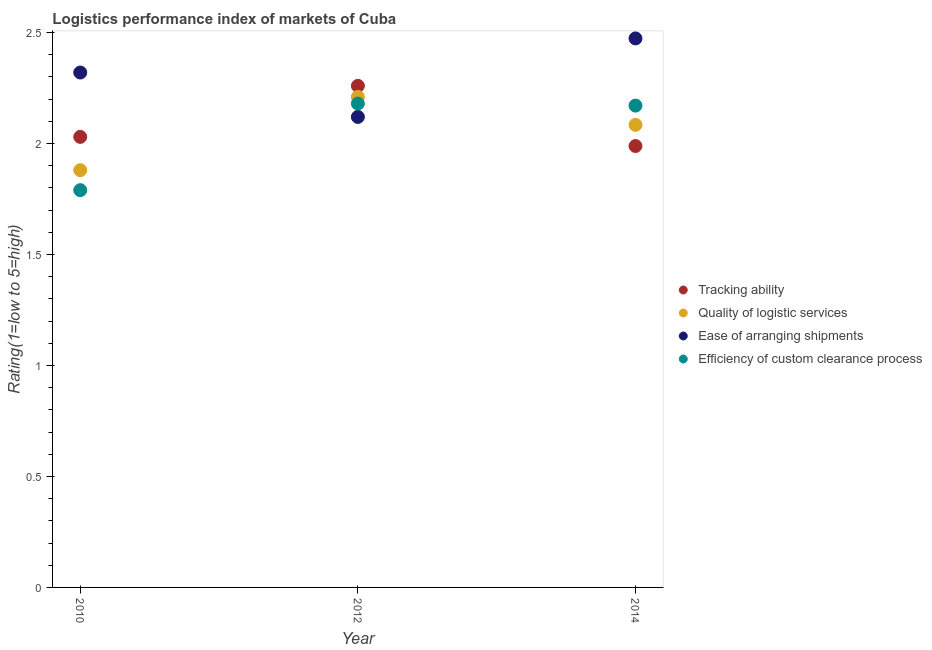How many different coloured dotlines are there?
Your response must be concise. 4. What is the lpi rating of ease of arranging shipments in 2012?
Your answer should be compact. 2.12. Across all years, what is the maximum lpi rating of quality of logistic services?
Offer a very short reply. 2.21. Across all years, what is the minimum lpi rating of ease of arranging shipments?
Your answer should be very brief. 2.12. In which year was the lpi rating of quality of logistic services maximum?
Offer a terse response. 2012. In which year was the lpi rating of tracking ability minimum?
Give a very brief answer. 2014. What is the total lpi rating of efficiency of custom clearance process in the graph?
Your answer should be compact. 6.14. What is the difference between the lpi rating of ease of arranging shipments in 2010 and that in 2014?
Provide a succinct answer. -0.15. What is the difference between the lpi rating of efficiency of custom clearance process in 2014 and the lpi rating of tracking ability in 2012?
Provide a short and direct response. -0.09. What is the average lpi rating of quality of logistic services per year?
Keep it short and to the point. 2.06. In the year 2010, what is the difference between the lpi rating of ease of arranging shipments and lpi rating of tracking ability?
Provide a short and direct response. 0.29. In how many years, is the lpi rating of quality of logistic services greater than 1.7?
Make the answer very short. 3. What is the ratio of the lpi rating of tracking ability in 2012 to that in 2014?
Offer a terse response. 1.14. Is the lpi rating of efficiency of custom clearance process in 2012 less than that in 2014?
Keep it short and to the point. No. Is the difference between the lpi rating of quality of logistic services in 2010 and 2012 greater than the difference between the lpi rating of ease of arranging shipments in 2010 and 2012?
Give a very brief answer. No. What is the difference between the highest and the second highest lpi rating of ease of arranging shipments?
Make the answer very short. 0.15. What is the difference between the highest and the lowest lpi rating of efficiency of custom clearance process?
Ensure brevity in your answer.  0.39. Is the sum of the lpi rating of ease of arranging shipments in 2012 and 2014 greater than the maximum lpi rating of tracking ability across all years?
Your answer should be very brief. Yes. Is it the case that in every year, the sum of the lpi rating of tracking ability and lpi rating of quality of logistic services is greater than the sum of lpi rating of efficiency of custom clearance process and lpi rating of ease of arranging shipments?
Make the answer very short. No. How many years are there in the graph?
Give a very brief answer. 3. What is the difference between two consecutive major ticks on the Y-axis?
Provide a short and direct response. 0.5. Are the values on the major ticks of Y-axis written in scientific E-notation?
Give a very brief answer. No. Does the graph contain any zero values?
Offer a terse response. No. How many legend labels are there?
Your answer should be very brief. 4. How are the legend labels stacked?
Your answer should be compact. Vertical. What is the title of the graph?
Provide a succinct answer. Logistics performance index of markets of Cuba. What is the label or title of the Y-axis?
Make the answer very short. Rating(1=low to 5=high). What is the Rating(1=low to 5=high) of Tracking ability in 2010?
Provide a succinct answer. 2.03. What is the Rating(1=low to 5=high) in Quality of logistic services in 2010?
Your answer should be very brief. 1.88. What is the Rating(1=low to 5=high) of Ease of arranging shipments in 2010?
Provide a succinct answer. 2.32. What is the Rating(1=low to 5=high) in Efficiency of custom clearance process in 2010?
Your response must be concise. 1.79. What is the Rating(1=low to 5=high) of Tracking ability in 2012?
Provide a short and direct response. 2.26. What is the Rating(1=low to 5=high) of Quality of logistic services in 2012?
Provide a succinct answer. 2.21. What is the Rating(1=low to 5=high) in Ease of arranging shipments in 2012?
Provide a short and direct response. 2.12. What is the Rating(1=low to 5=high) in Efficiency of custom clearance process in 2012?
Provide a short and direct response. 2.18. What is the Rating(1=low to 5=high) in Tracking ability in 2014?
Your response must be concise. 1.99. What is the Rating(1=low to 5=high) in Quality of logistic services in 2014?
Provide a succinct answer. 2.08. What is the Rating(1=low to 5=high) in Ease of arranging shipments in 2014?
Your response must be concise. 2.47. What is the Rating(1=low to 5=high) in Efficiency of custom clearance process in 2014?
Offer a terse response. 2.17. Across all years, what is the maximum Rating(1=low to 5=high) of Tracking ability?
Offer a very short reply. 2.26. Across all years, what is the maximum Rating(1=low to 5=high) in Quality of logistic services?
Give a very brief answer. 2.21. Across all years, what is the maximum Rating(1=low to 5=high) in Ease of arranging shipments?
Your answer should be compact. 2.47. Across all years, what is the maximum Rating(1=low to 5=high) of Efficiency of custom clearance process?
Provide a succinct answer. 2.18. Across all years, what is the minimum Rating(1=low to 5=high) of Tracking ability?
Ensure brevity in your answer.  1.99. Across all years, what is the minimum Rating(1=low to 5=high) in Quality of logistic services?
Your answer should be very brief. 1.88. Across all years, what is the minimum Rating(1=low to 5=high) in Ease of arranging shipments?
Provide a short and direct response. 2.12. Across all years, what is the minimum Rating(1=low to 5=high) of Efficiency of custom clearance process?
Keep it short and to the point. 1.79. What is the total Rating(1=low to 5=high) of Tracking ability in the graph?
Give a very brief answer. 6.28. What is the total Rating(1=low to 5=high) in Quality of logistic services in the graph?
Make the answer very short. 6.17. What is the total Rating(1=low to 5=high) of Ease of arranging shipments in the graph?
Your answer should be very brief. 6.91. What is the total Rating(1=low to 5=high) of Efficiency of custom clearance process in the graph?
Your response must be concise. 6.14. What is the difference between the Rating(1=low to 5=high) of Tracking ability in 2010 and that in 2012?
Ensure brevity in your answer.  -0.23. What is the difference between the Rating(1=low to 5=high) in Quality of logistic services in 2010 and that in 2012?
Your answer should be compact. -0.33. What is the difference between the Rating(1=low to 5=high) of Ease of arranging shipments in 2010 and that in 2012?
Your answer should be very brief. 0.2. What is the difference between the Rating(1=low to 5=high) of Efficiency of custom clearance process in 2010 and that in 2012?
Your response must be concise. -0.39. What is the difference between the Rating(1=low to 5=high) of Tracking ability in 2010 and that in 2014?
Give a very brief answer. 0.04. What is the difference between the Rating(1=low to 5=high) in Quality of logistic services in 2010 and that in 2014?
Provide a short and direct response. -0.2. What is the difference between the Rating(1=low to 5=high) of Ease of arranging shipments in 2010 and that in 2014?
Offer a terse response. -0.15. What is the difference between the Rating(1=low to 5=high) of Efficiency of custom clearance process in 2010 and that in 2014?
Make the answer very short. -0.38. What is the difference between the Rating(1=low to 5=high) of Tracking ability in 2012 and that in 2014?
Provide a succinct answer. 0.27. What is the difference between the Rating(1=low to 5=high) of Quality of logistic services in 2012 and that in 2014?
Offer a terse response. 0.13. What is the difference between the Rating(1=low to 5=high) of Ease of arranging shipments in 2012 and that in 2014?
Keep it short and to the point. -0.35. What is the difference between the Rating(1=low to 5=high) of Efficiency of custom clearance process in 2012 and that in 2014?
Ensure brevity in your answer.  0.01. What is the difference between the Rating(1=low to 5=high) in Tracking ability in 2010 and the Rating(1=low to 5=high) in Quality of logistic services in 2012?
Your answer should be very brief. -0.18. What is the difference between the Rating(1=low to 5=high) of Tracking ability in 2010 and the Rating(1=low to 5=high) of Ease of arranging shipments in 2012?
Keep it short and to the point. -0.09. What is the difference between the Rating(1=low to 5=high) in Tracking ability in 2010 and the Rating(1=low to 5=high) in Efficiency of custom clearance process in 2012?
Offer a terse response. -0.15. What is the difference between the Rating(1=low to 5=high) of Quality of logistic services in 2010 and the Rating(1=low to 5=high) of Ease of arranging shipments in 2012?
Make the answer very short. -0.24. What is the difference between the Rating(1=low to 5=high) in Ease of arranging shipments in 2010 and the Rating(1=low to 5=high) in Efficiency of custom clearance process in 2012?
Provide a succinct answer. 0.14. What is the difference between the Rating(1=low to 5=high) in Tracking ability in 2010 and the Rating(1=low to 5=high) in Quality of logistic services in 2014?
Your answer should be compact. -0.05. What is the difference between the Rating(1=low to 5=high) of Tracking ability in 2010 and the Rating(1=low to 5=high) of Ease of arranging shipments in 2014?
Keep it short and to the point. -0.44. What is the difference between the Rating(1=low to 5=high) in Tracking ability in 2010 and the Rating(1=low to 5=high) in Efficiency of custom clearance process in 2014?
Give a very brief answer. -0.14. What is the difference between the Rating(1=low to 5=high) in Quality of logistic services in 2010 and the Rating(1=low to 5=high) in Ease of arranging shipments in 2014?
Give a very brief answer. -0.59. What is the difference between the Rating(1=low to 5=high) in Quality of logistic services in 2010 and the Rating(1=low to 5=high) in Efficiency of custom clearance process in 2014?
Provide a succinct answer. -0.29. What is the difference between the Rating(1=low to 5=high) of Ease of arranging shipments in 2010 and the Rating(1=low to 5=high) of Efficiency of custom clearance process in 2014?
Give a very brief answer. 0.15. What is the difference between the Rating(1=low to 5=high) of Tracking ability in 2012 and the Rating(1=low to 5=high) of Quality of logistic services in 2014?
Your answer should be compact. 0.18. What is the difference between the Rating(1=low to 5=high) in Tracking ability in 2012 and the Rating(1=low to 5=high) in Ease of arranging shipments in 2014?
Your answer should be compact. -0.21. What is the difference between the Rating(1=low to 5=high) of Tracking ability in 2012 and the Rating(1=low to 5=high) of Efficiency of custom clearance process in 2014?
Keep it short and to the point. 0.09. What is the difference between the Rating(1=low to 5=high) in Quality of logistic services in 2012 and the Rating(1=low to 5=high) in Ease of arranging shipments in 2014?
Provide a succinct answer. -0.26. What is the difference between the Rating(1=low to 5=high) in Quality of logistic services in 2012 and the Rating(1=low to 5=high) in Efficiency of custom clearance process in 2014?
Provide a short and direct response. 0.04. What is the difference between the Rating(1=low to 5=high) in Ease of arranging shipments in 2012 and the Rating(1=low to 5=high) in Efficiency of custom clearance process in 2014?
Ensure brevity in your answer.  -0.05. What is the average Rating(1=low to 5=high) of Tracking ability per year?
Your answer should be compact. 2.09. What is the average Rating(1=low to 5=high) of Quality of logistic services per year?
Keep it short and to the point. 2.06. What is the average Rating(1=low to 5=high) of Ease of arranging shipments per year?
Offer a terse response. 2.3. What is the average Rating(1=low to 5=high) of Efficiency of custom clearance process per year?
Provide a succinct answer. 2.05. In the year 2010, what is the difference between the Rating(1=low to 5=high) of Tracking ability and Rating(1=low to 5=high) of Ease of arranging shipments?
Keep it short and to the point. -0.29. In the year 2010, what is the difference between the Rating(1=low to 5=high) in Tracking ability and Rating(1=low to 5=high) in Efficiency of custom clearance process?
Offer a very short reply. 0.24. In the year 2010, what is the difference between the Rating(1=low to 5=high) in Quality of logistic services and Rating(1=low to 5=high) in Ease of arranging shipments?
Provide a short and direct response. -0.44. In the year 2010, what is the difference between the Rating(1=low to 5=high) in Quality of logistic services and Rating(1=low to 5=high) in Efficiency of custom clearance process?
Your response must be concise. 0.09. In the year 2010, what is the difference between the Rating(1=low to 5=high) of Ease of arranging shipments and Rating(1=low to 5=high) of Efficiency of custom clearance process?
Give a very brief answer. 0.53. In the year 2012, what is the difference between the Rating(1=low to 5=high) of Tracking ability and Rating(1=low to 5=high) of Quality of logistic services?
Ensure brevity in your answer.  0.05. In the year 2012, what is the difference between the Rating(1=low to 5=high) in Tracking ability and Rating(1=low to 5=high) in Ease of arranging shipments?
Provide a succinct answer. 0.14. In the year 2012, what is the difference between the Rating(1=low to 5=high) of Tracking ability and Rating(1=low to 5=high) of Efficiency of custom clearance process?
Give a very brief answer. 0.08. In the year 2012, what is the difference between the Rating(1=low to 5=high) of Quality of logistic services and Rating(1=low to 5=high) of Ease of arranging shipments?
Keep it short and to the point. 0.09. In the year 2012, what is the difference between the Rating(1=low to 5=high) in Quality of logistic services and Rating(1=low to 5=high) in Efficiency of custom clearance process?
Your answer should be compact. 0.03. In the year 2012, what is the difference between the Rating(1=low to 5=high) of Ease of arranging shipments and Rating(1=low to 5=high) of Efficiency of custom clearance process?
Offer a terse response. -0.06. In the year 2014, what is the difference between the Rating(1=low to 5=high) in Tracking ability and Rating(1=low to 5=high) in Quality of logistic services?
Keep it short and to the point. -0.1. In the year 2014, what is the difference between the Rating(1=low to 5=high) of Tracking ability and Rating(1=low to 5=high) of Ease of arranging shipments?
Make the answer very short. -0.48. In the year 2014, what is the difference between the Rating(1=low to 5=high) in Tracking ability and Rating(1=low to 5=high) in Efficiency of custom clearance process?
Your response must be concise. -0.18. In the year 2014, what is the difference between the Rating(1=low to 5=high) in Quality of logistic services and Rating(1=low to 5=high) in Ease of arranging shipments?
Make the answer very short. -0.39. In the year 2014, what is the difference between the Rating(1=low to 5=high) of Quality of logistic services and Rating(1=low to 5=high) of Efficiency of custom clearance process?
Offer a very short reply. -0.09. In the year 2014, what is the difference between the Rating(1=low to 5=high) in Ease of arranging shipments and Rating(1=low to 5=high) in Efficiency of custom clearance process?
Your response must be concise. 0.3. What is the ratio of the Rating(1=low to 5=high) in Tracking ability in 2010 to that in 2012?
Offer a terse response. 0.9. What is the ratio of the Rating(1=low to 5=high) in Quality of logistic services in 2010 to that in 2012?
Provide a short and direct response. 0.85. What is the ratio of the Rating(1=low to 5=high) in Ease of arranging shipments in 2010 to that in 2012?
Your answer should be compact. 1.09. What is the ratio of the Rating(1=low to 5=high) in Efficiency of custom clearance process in 2010 to that in 2012?
Offer a terse response. 0.82. What is the ratio of the Rating(1=low to 5=high) of Tracking ability in 2010 to that in 2014?
Your answer should be very brief. 1.02. What is the ratio of the Rating(1=low to 5=high) of Quality of logistic services in 2010 to that in 2014?
Give a very brief answer. 0.9. What is the ratio of the Rating(1=low to 5=high) in Ease of arranging shipments in 2010 to that in 2014?
Make the answer very short. 0.94. What is the ratio of the Rating(1=low to 5=high) of Efficiency of custom clearance process in 2010 to that in 2014?
Give a very brief answer. 0.82. What is the ratio of the Rating(1=low to 5=high) in Tracking ability in 2012 to that in 2014?
Your answer should be compact. 1.14. What is the ratio of the Rating(1=low to 5=high) in Quality of logistic services in 2012 to that in 2014?
Your answer should be compact. 1.06. What is the ratio of the Rating(1=low to 5=high) in Ease of arranging shipments in 2012 to that in 2014?
Your response must be concise. 0.86. What is the difference between the highest and the second highest Rating(1=low to 5=high) in Tracking ability?
Offer a very short reply. 0.23. What is the difference between the highest and the second highest Rating(1=low to 5=high) in Quality of logistic services?
Provide a short and direct response. 0.13. What is the difference between the highest and the second highest Rating(1=low to 5=high) of Ease of arranging shipments?
Give a very brief answer. 0.15. What is the difference between the highest and the second highest Rating(1=low to 5=high) of Efficiency of custom clearance process?
Your answer should be very brief. 0.01. What is the difference between the highest and the lowest Rating(1=low to 5=high) in Tracking ability?
Provide a succinct answer. 0.27. What is the difference between the highest and the lowest Rating(1=low to 5=high) in Quality of logistic services?
Offer a very short reply. 0.33. What is the difference between the highest and the lowest Rating(1=low to 5=high) of Ease of arranging shipments?
Provide a short and direct response. 0.35. What is the difference between the highest and the lowest Rating(1=low to 5=high) in Efficiency of custom clearance process?
Your answer should be compact. 0.39. 